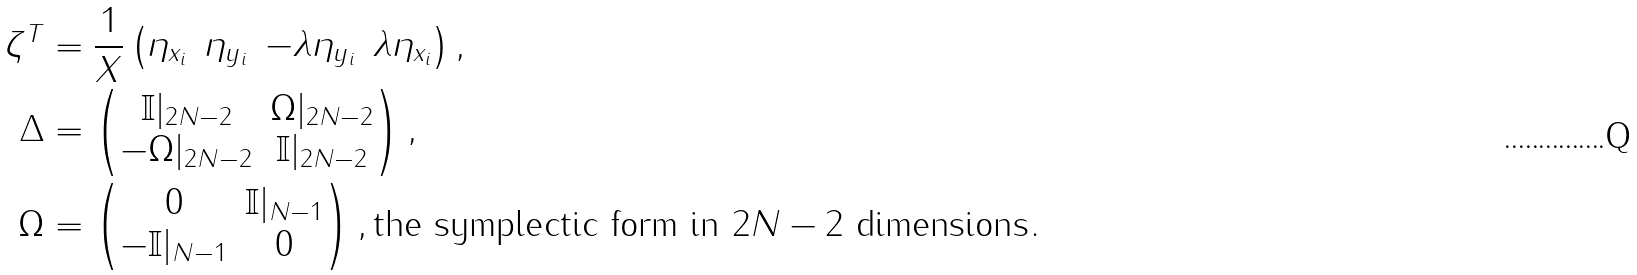Convert formula to latex. <formula><loc_0><loc_0><loc_500><loc_500>\zeta ^ { T } & = \frac { 1 } { X } \begin{pmatrix} \eta _ { x _ { i } } & \eta _ { y _ { i } } & - \lambda \eta _ { y _ { i } } & \lambda \eta _ { x _ { i } } \end{pmatrix} , \\ \Delta & = \begin{pmatrix} \mathbb { I } | _ { 2 N - 2 } & \Omega | _ { 2 N - 2 } \\ - \Omega | _ { 2 N - 2 } & \mathbb { I } | _ { 2 N - 2 } \end{pmatrix} , \\ \Omega & = \begin{pmatrix} 0 & \mathbb { I } | _ { N - 1 } \\ - \mathbb { I } | _ { N - 1 } & 0 \end{pmatrix} , \text {the symplectic form in $2N-2$ dimensions} .</formula> 